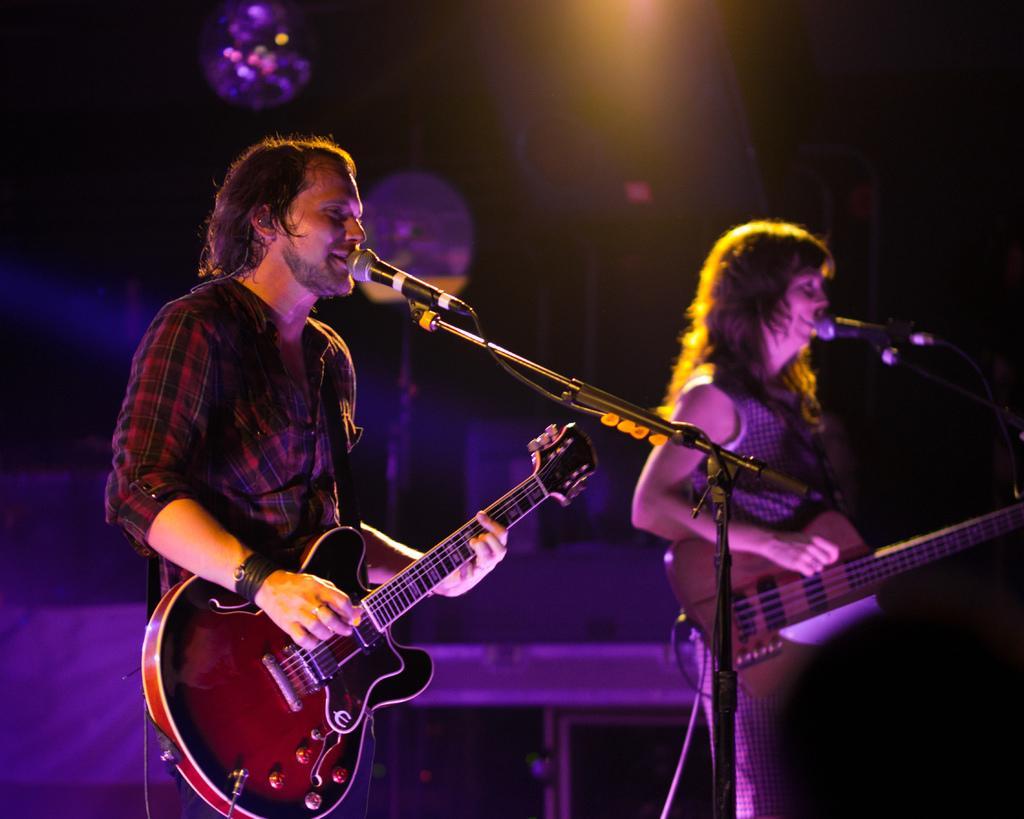Describe this image in one or two sentences. In this picture a man is playing guitar in front of microphone and a woman also playing guitar in front of microphone in the background we can see couple of lights. 